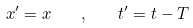Convert formula to latex. <formula><loc_0><loc_0><loc_500><loc_500>x ^ { \prime } = x \quad , \quad t ^ { \prime } = t - T</formula> 